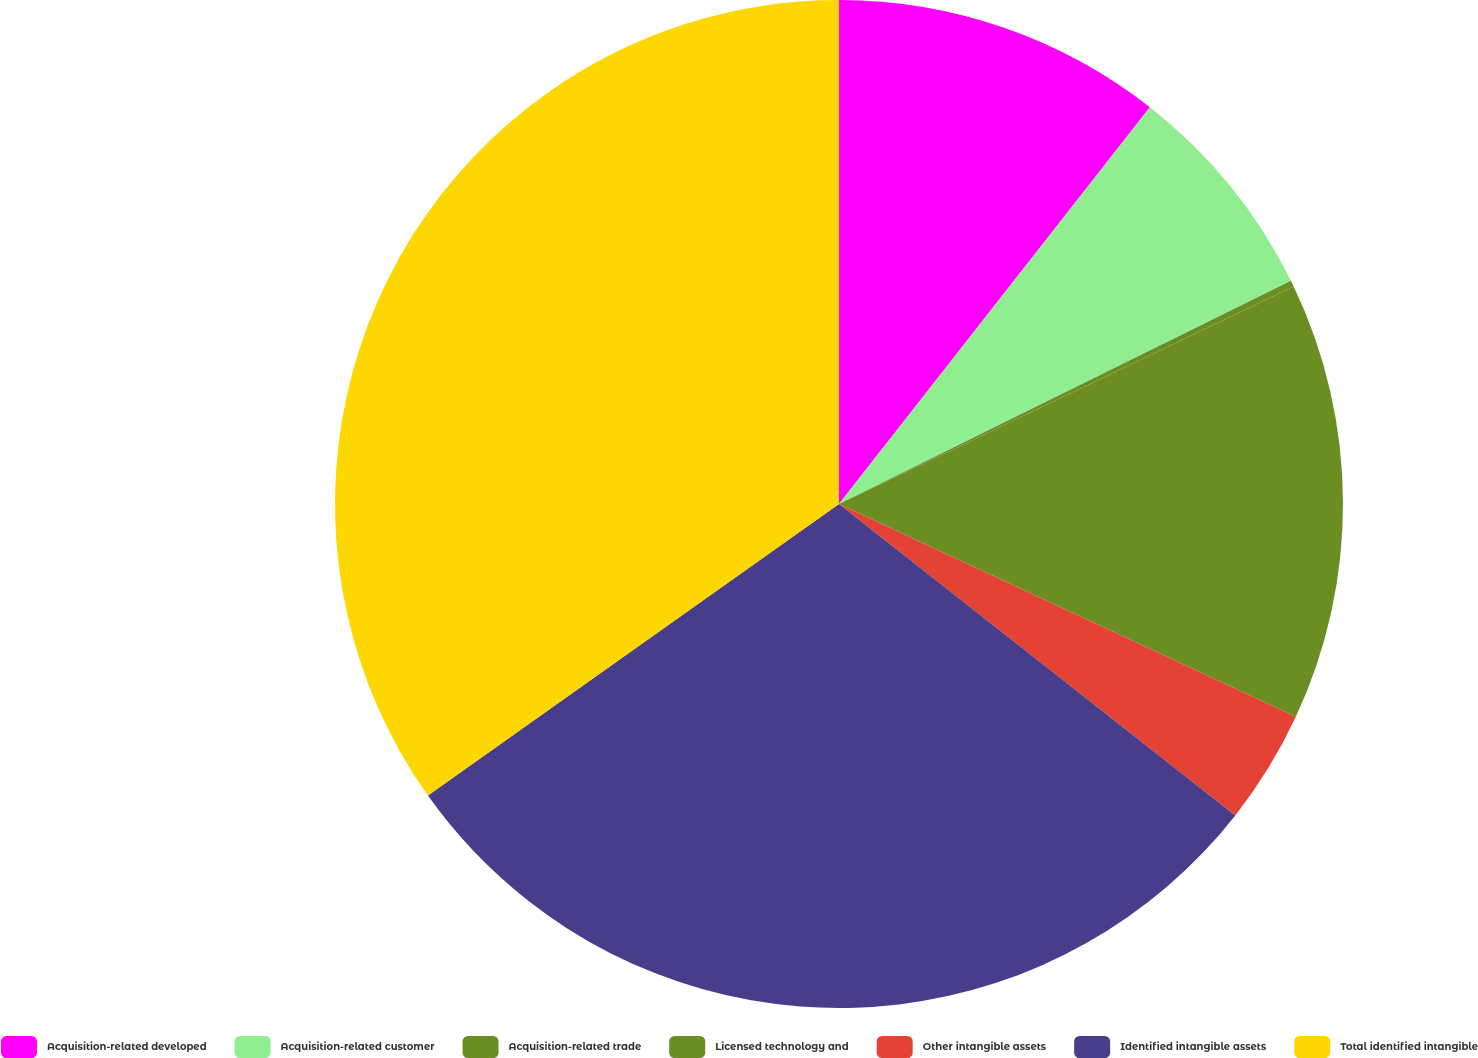<chart> <loc_0><loc_0><loc_500><loc_500><pie_chart><fcel>Acquisition-related developed<fcel>Acquisition-related customer<fcel>Acquisition-related trade<fcel>Licensed technology and<fcel>Other intangible assets<fcel>Identified intangible assets<fcel>Total identified intangible<nl><fcel>10.58%<fcel>7.12%<fcel>0.2%<fcel>14.04%<fcel>3.66%<fcel>29.58%<fcel>34.82%<nl></chart> 